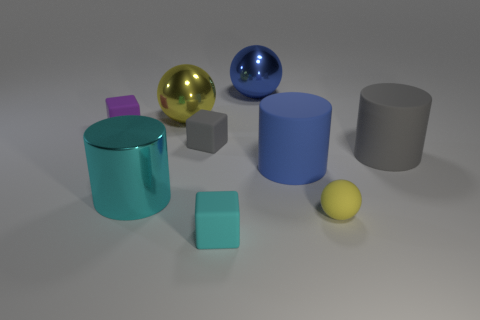There is a blue sphere; are there any rubber objects to the right of it?
Provide a short and direct response. Yes. What number of other things are the same shape as the large yellow thing?
Offer a terse response. 2. What is the color of the big shiny thing that is in front of the tiny object left of the large sphere on the left side of the blue metallic object?
Give a very brief answer. Cyan. Is the material of the big cylinder that is on the right side of the small yellow object the same as the small block that is in front of the small gray cube?
Your answer should be compact. Yes. How many objects are big blue matte things on the right side of the purple block or large blue cylinders?
Provide a succinct answer. 1. How many things are cyan matte blocks or rubber cubes right of the gray rubber block?
Provide a short and direct response. 1. How many blue rubber objects are the same size as the blue rubber cylinder?
Make the answer very short. 0. Are there fewer large blue balls left of the blue sphere than metal things behind the blue cylinder?
Offer a terse response. Yes. How many rubber objects are either big cyan blocks or tiny things?
Offer a very short reply. 4. What is the shape of the small cyan object?
Give a very brief answer. Cube. 